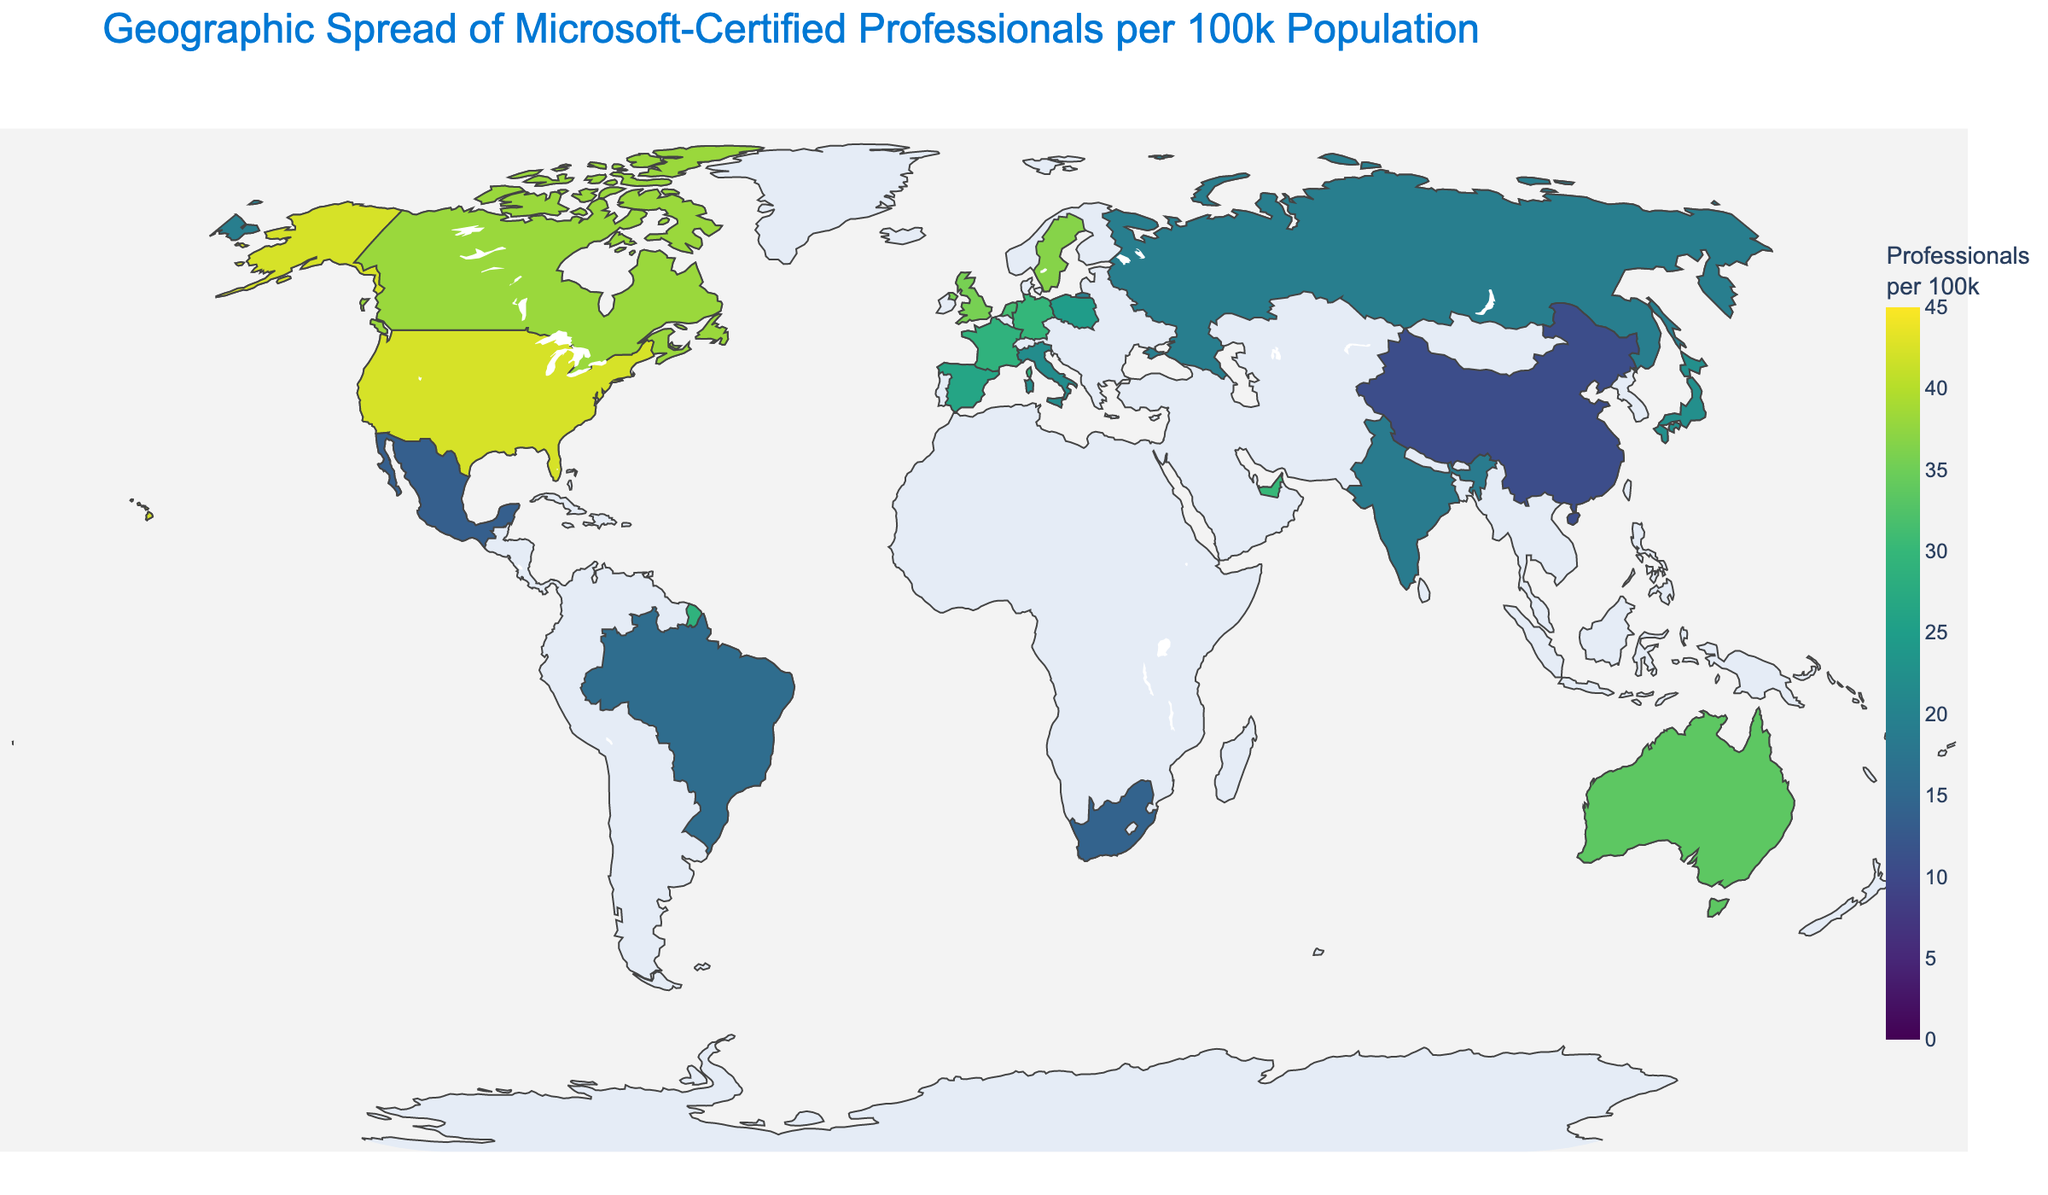What is the title of the figure? The title is usually placed at the top of the figure to immediately inform the viewer of what the data represents. In this case, it's written prominently.
Answer: Geographic Spread of Microsoft-Certified Professionals per 100k Population Which country has the highest number of Microsoft-certified professionals per 100k population? By looking at the color legend and comparing the colors on the map, the United States has the highest value at 42.3 professionals per 100k population, indicated by the darkest shade of the color scale.
Answer: United States What is the range of professionals per 100k population shown by the color bar? The continuous color bar to the right of the figure shows the range from the lowest to the highest values. The scale starts at 0 and goes up to 45.
Answer: 0 to 45 How many countries fall within the range of 30 to 40 professionals per 100k population? By looking at the color shades associated with the range of 30 to 40 on the color bar and counting the countries with those colors on the map, there are six countries: United Kingdom, Canada, Australia, Netherlands, Sweden, and Singapore.
Answer: 6 Which region has the greatest diversity in the number of professionals per 100k population? By comparing the values of different regions, Europe has a wide range from 10.6 in Russia to 36.7 in Sweden, indicating high diversity.
Answer: Europe Compare the number of professionals per 100k population between Japan and China. Which country has more, and by how much? Japan has 22.4 professionals per 100k, and China has 10.6. Subtract China's value from Japan's: 22.4 - 10.6 = 11.8. So, Japan has 11.8 more professionals per 100k than China.
Answer: Japan by 11.8 What is the median number of professionals per 100k population across all the countries shown? Arrange the numbers in ascending order: 10.6, 13.5, 14.2, 15.9, 18.7, 19.3, 21.8, 22.4, 24.6, 26.3, 28.9, 29.8, 30.1, 31.2, 33.5, 35.6, 36.7, 38.1, 40.5, 42.3. The median (middle) value for 20 entries is the average of the 10th and 11th values: (26.3 + 28.9)/2 = 27.6.
Answer: 27.6 Which countries have a number of professionals per 100k population greater than and closest to 35? The countries with numbers closest to and higher than 35 are Sweden (36.7) and United Kingdom (35.6).
Answer: Sweden and United Kingdom Between Mexico and Brazil, which country has fewer professionals per 100k population? Mexico has 13.5, and Brazil has 15.9 professionals per 100k. Since 13.5 is less than 15.9, Mexico has fewer professionals per 100k.
Answer: Mexico What is the average number of professionals per 100k population for North American countries? North America includes the United States (42.3), Canada (38.1), and Mexico (13.5). Calculate the average: (42.3 + 38.1 + 13.5) / 3 = 31.3.
Answer: 31.3 